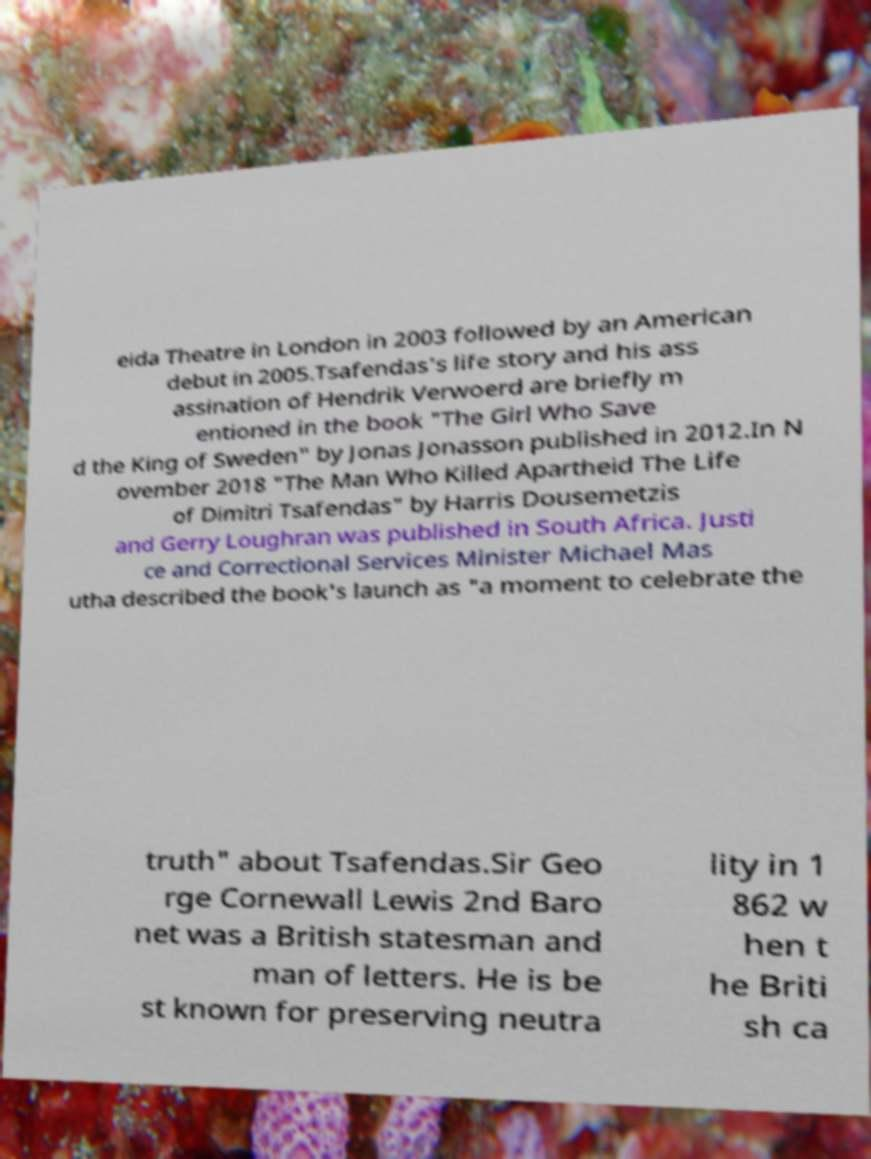Please read and relay the text visible in this image. What does it say? eida Theatre in London in 2003 followed by an American debut in 2005.Tsafendas's life story and his ass assination of Hendrik Verwoerd are briefly m entioned in the book "The Girl Who Save d the King of Sweden" by Jonas Jonasson published in 2012.In N ovember 2018 "The Man Who Killed Apartheid The Life of Dimitri Tsafendas" by Harris Dousemetzis and Gerry Loughran was published in South Africa. Justi ce and Correctional Services Minister Michael Mas utha described the book's launch as "a moment to celebrate the truth" about Tsafendas.Sir Geo rge Cornewall Lewis 2nd Baro net was a British statesman and man of letters. He is be st known for preserving neutra lity in 1 862 w hen t he Briti sh ca 